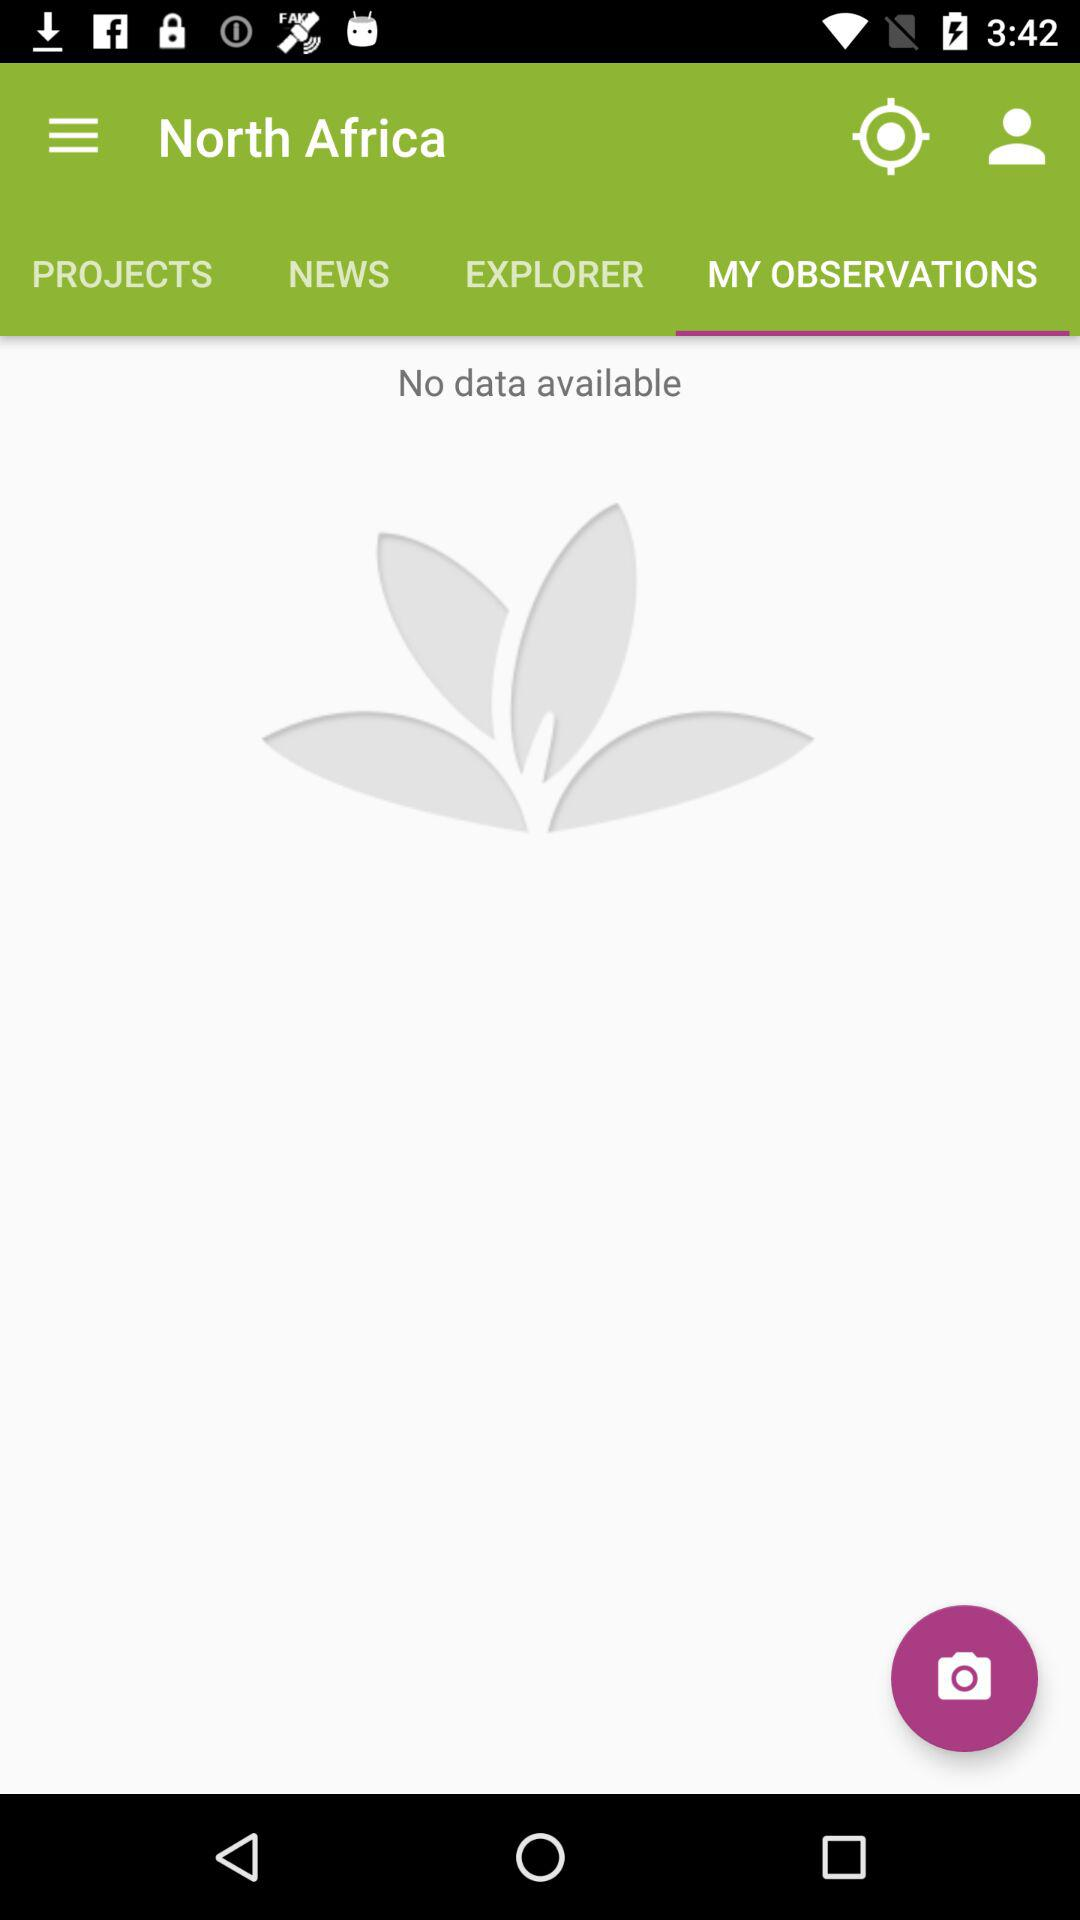Which tab has been selected? The selected tab is "MY OBSERVATION". 